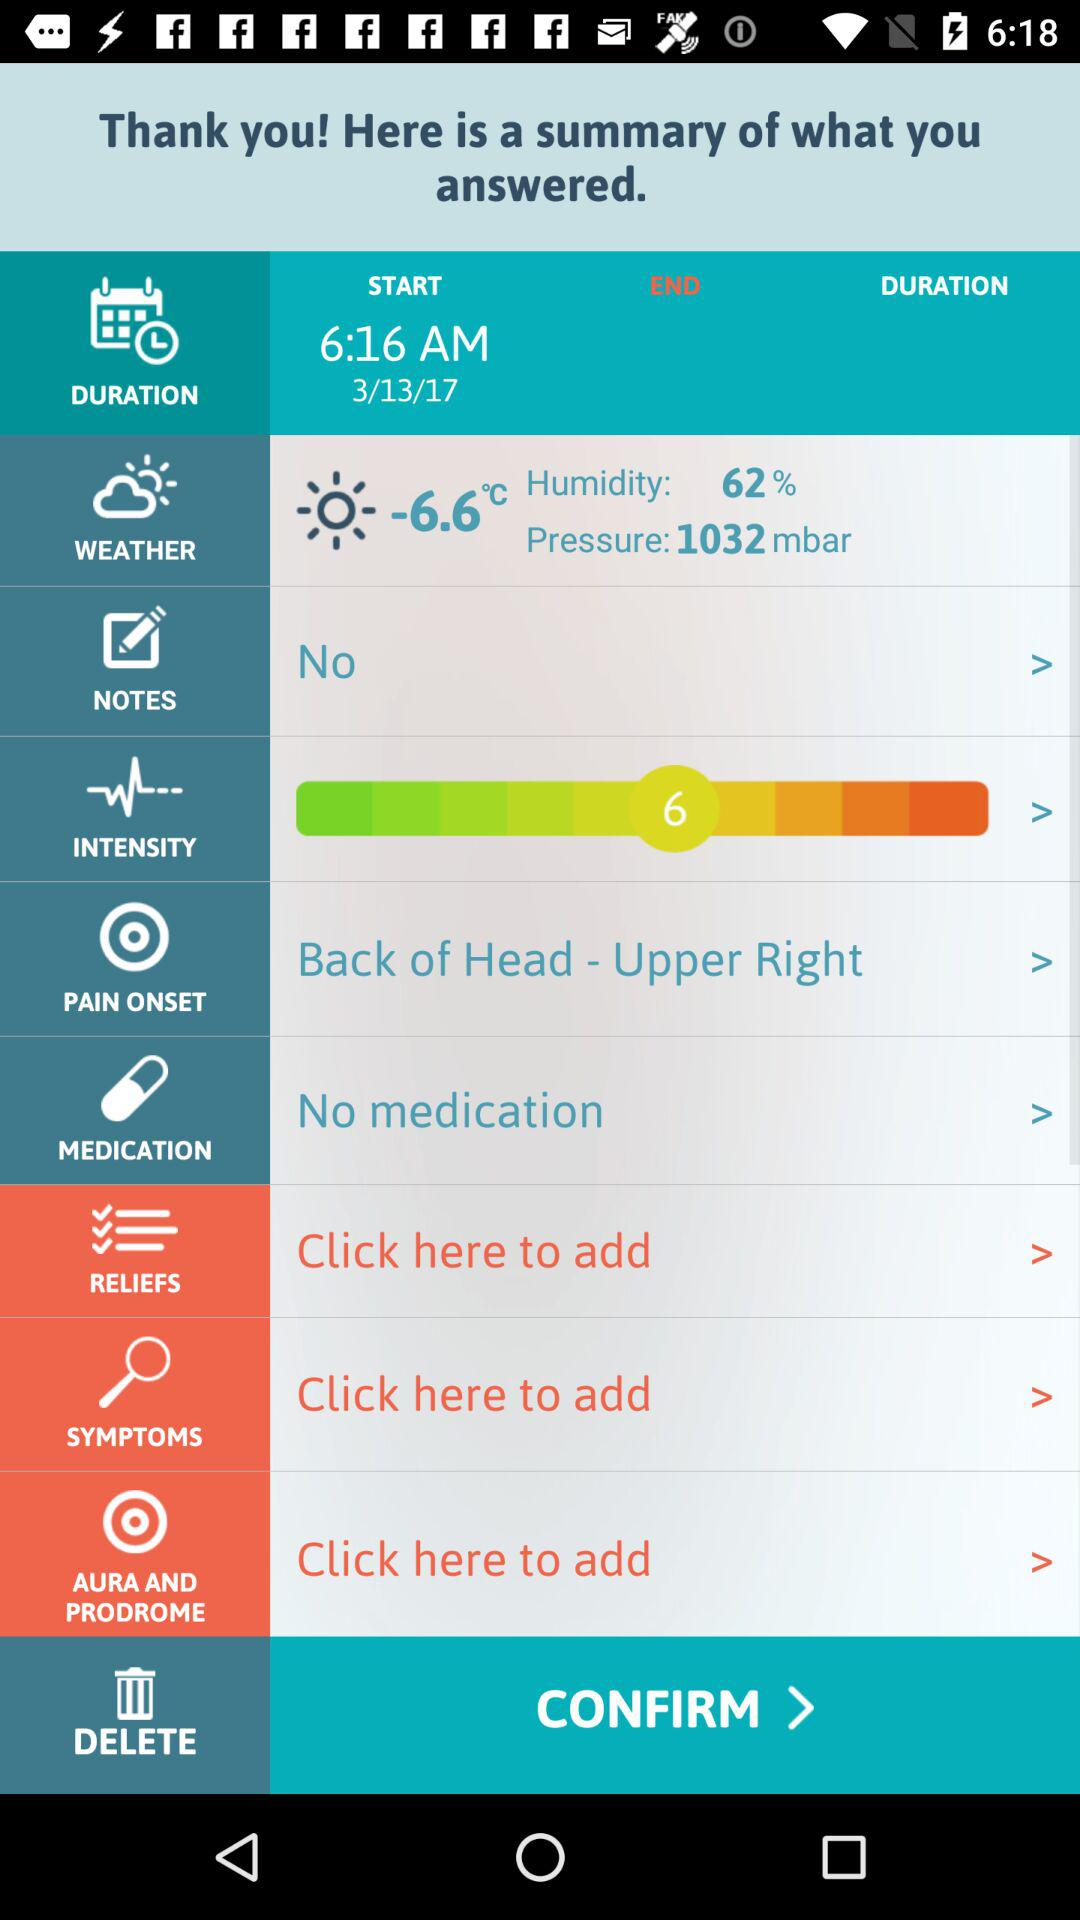What is the level of intensity? The level of intensity is 6. 